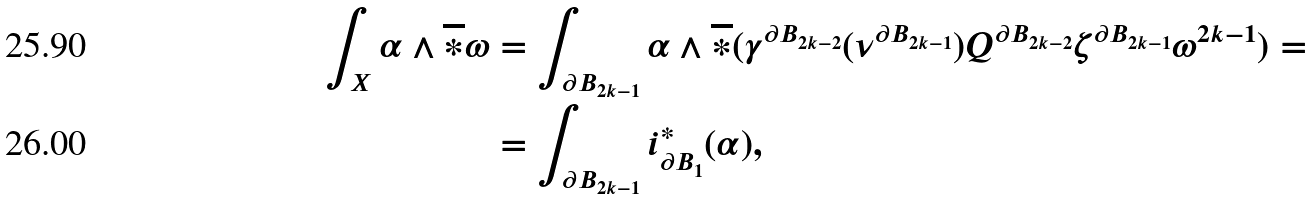<formula> <loc_0><loc_0><loc_500><loc_500>\int _ { X } \alpha \wedge \overline { * } \omega & = \int _ { \partial B _ { 2 k - 1 } } \alpha \wedge \overline { * } ( \gamma ^ { \partial B _ { 2 k - 2 } } ( \nu ^ { \partial B _ { 2 k - 1 } } ) Q ^ { \partial B _ { 2 k - 2 } } \zeta ^ { \partial B _ { 2 k - 1 } } \omega ^ { 2 k - 1 } ) = \\ & = \int _ { \partial B _ { 2 k - 1 } } i _ { \partial B _ { 1 } } ^ { * } ( \alpha ) ,</formula> 